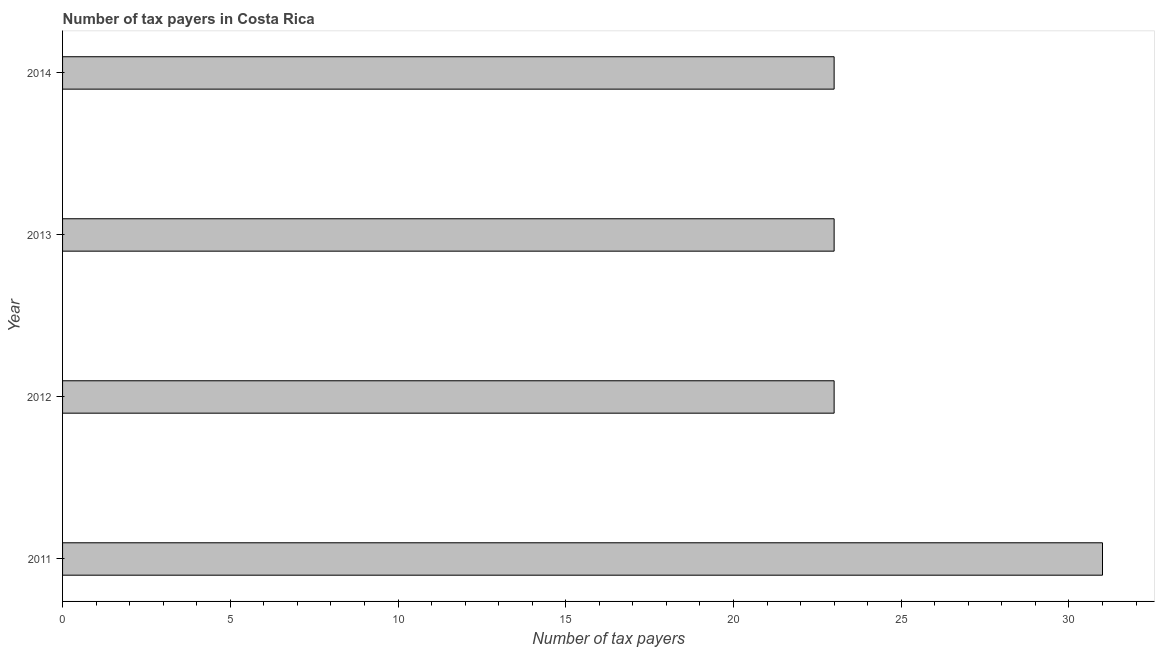Does the graph contain any zero values?
Give a very brief answer. No. What is the title of the graph?
Make the answer very short. Number of tax payers in Costa Rica. What is the label or title of the X-axis?
Make the answer very short. Number of tax payers. In which year was the number of tax payers minimum?
Provide a succinct answer. 2012. What is the difference between the number of tax payers in 2011 and 2012?
Offer a very short reply. 8. What is the median number of tax payers?
Provide a short and direct response. 23. In how many years, is the number of tax payers greater than 29 ?
Your response must be concise. 1. Is the difference between the number of tax payers in 2011 and 2013 greater than the difference between any two years?
Keep it short and to the point. Yes. Are all the bars in the graph horizontal?
Keep it short and to the point. Yes. What is the difference between two consecutive major ticks on the X-axis?
Make the answer very short. 5. Are the values on the major ticks of X-axis written in scientific E-notation?
Your response must be concise. No. What is the Number of tax payers of 2011?
Make the answer very short. 31. What is the Number of tax payers of 2012?
Your response must be concise. 23. What is the Number of tax payers in 2014?
Your answer should be very brief. 23. What is the difference between the Number of tax payers in 2011 and 2012?
Offer a terse response. 8. What is the difference between the Number of tax payers in 2011 and 2014?
Make the answer very short. 8. What is the difference between the Number of tax payers in 2013 and 2014?
Keep it short and to the point. 0. What is the ratio of the Number of tax payers in 2011 to that in 2012?
Offer a very short reply. 1.35. What is the ratio of the Number of tax payers in 2011 to that in 2013?
Provide a succinct answer. 1.35. What is the ratio of the Number of tax payers in 2011 to that in 2014?
Provide a succinct answer. 1.35. What is the ratio of the Number of tax payers in 2012 to that in 2014?
Your response must be concise. 1. What is the ratio of the Number of tax payers in 2013 to that in 2014?
Your answer should be very brief. 1. 